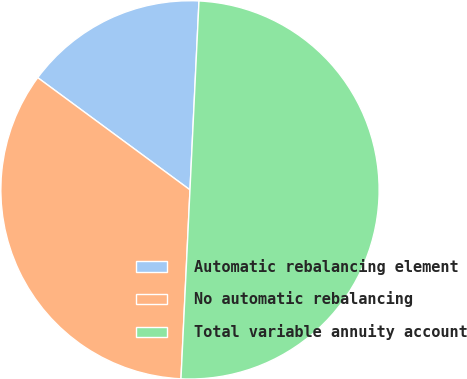Convert chart. <chart><loc_0><loc_0><loc_500><loc_500><pie_chart><fcel>Automatic rebalancing element<fcel>No automatic rebalancing<fcel>Total variable annuity account<nl><fcel>15.65%<fcel>34.35%<fcel>50.0%<nl></chart> 